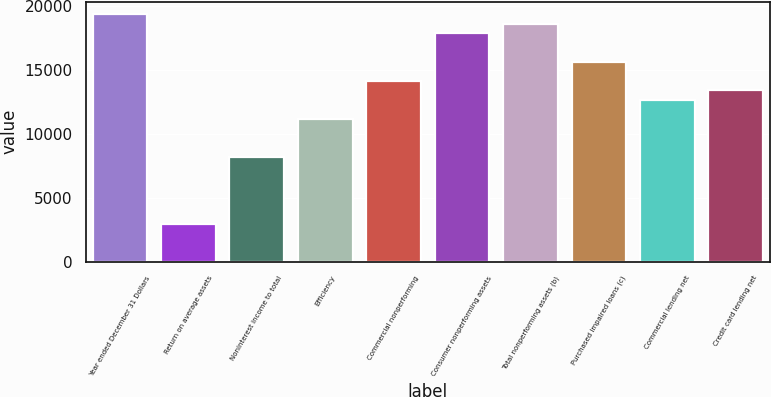<chart> <loc_0><loc_0><loc_500><loc_500><bar_chart><fcel>Year ended December 31 Dollars<fcel>Return on average assets<fcel>Noninterest income to total<fcel>Efficiency<fcel>Commercial nonperforming<fcel>Consumer nonperforming assets<fcel>Total nonperforming assets (b)<fcel>Purchased impaired loans (c)<fcel>Commercial lending net<fcel>Credit card lending net<nl><fcel>19356.8<fcel>2978.05<fcel>8189.48<fcel>11167.4<fcel>14145.4<fcel>17867.8<fcel>18612.3<fcel>15634.4<fcel>12656.4<fcel>13400.9<nl></chart> 